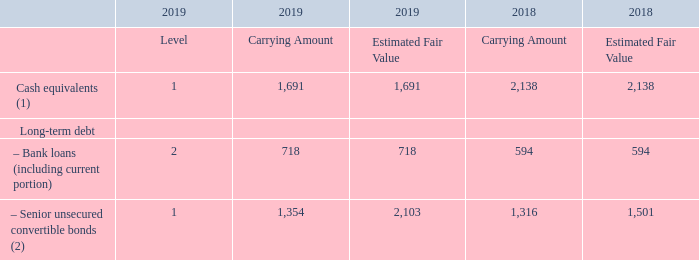The following table includes additional fair value information on financial assets and liabilities as at December 31, 2019 and 2018:
(1) Cash equivalents primarily correspond to deposits at call with banks.
(2) The carrying amount of the senior unsecured convertible bonds as reported above corresponds to the liability component only. For the convertible bonds issued on July 3, 2017 and outstanding as at December 31, 2017, the carrying amount of the senior unsecured convertible bonds corresponds to the liability component only, since, at initial recognition, an amount of $242 million was recorded directly in shareholders’ equity as the value of the equity instrument embedded in the convertible instrument.
What is the correspond of Cash equivalents? Cash equivalents primarily correspond to deposits at call with banks. Under which head of balance sheet does senior unsecured convertible bonds correspond to? The carrying amount of the senior unsecured convertible bonds as reported above corresponds to the liability component only. How much amount was recorded in shareholders’ equity as the value of the equity instrument embedded in the convertible instrument? $242 million. What is the increase/ (decrease) in Cash equivalents of Carrying Amount from 2018 to 2019?
Answer scale should be: million. 1,691-2,138
Answer: -447. What is the increase/ (decrease) in Bank loans (including current portion) of Carrying Amount from 2018 to 2019?
Answer scale should be: million. 718-594
Answer: 124. What is the increase/ (decrease) in Senior unsecured convertible bonds of Carrying Amount from 2018 to 2019?
Answer scale should be: million. 1,354-1,316
Answer: 38. 